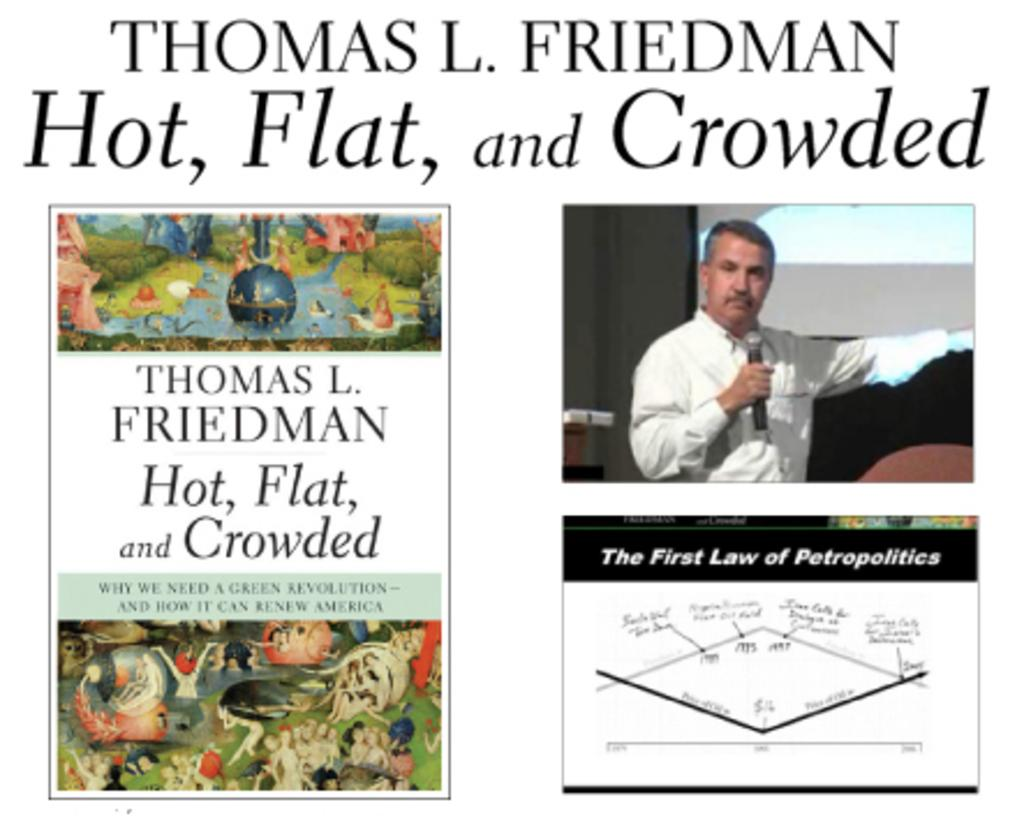What is the person in the image doing? The person is standing in the image and holding a microphone. What else can be seen in the image besides the person? There are cartoon pictures and text written on the image. How many legs does the person have in the image? The person in the image has two legs, but this question is irrelevant as the number of legs is not mentioned in the facts provided. 